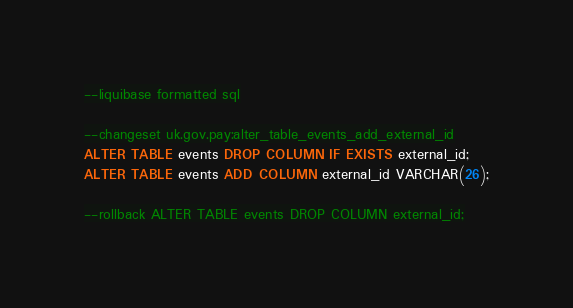<code> <loc_0><loc_0><loc_500><loc_500><_SQL_>--liquibase formatted sql

--changeset uk.gov.pay:alter_table_events_add_external_id
ALTER TABLE events DROP COLUMN IF EXISTS external_id;
ALTER TABLE events ADD COLUMN external_id VARCHAR(26);

--rollback ALTER TABLE events DROP COLUMN external_id;</code> 